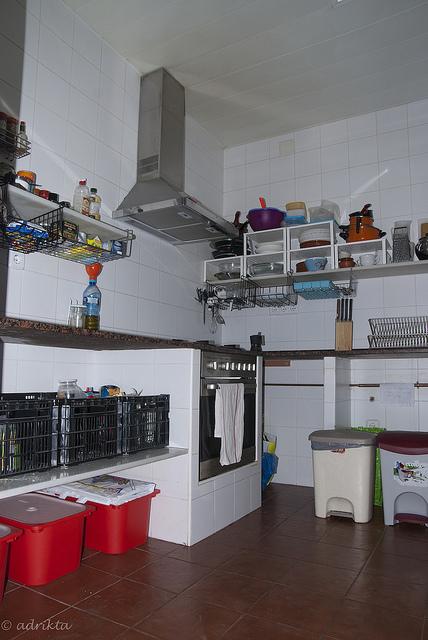What is above the stove?
Answer briefly. Vent. Can you see a microwave?
Concise answer only. No. Are there baskets in the window?
Quick response, please. No. What is the counter made of?
Concise answer only. Wood. Is there a dishwasher in the photo?
Short answer required. No. How many storage bins are there in this picture?
Write a very short answer. 6. Is there a box of cereal on the shelf?
Keep it brief. No. 